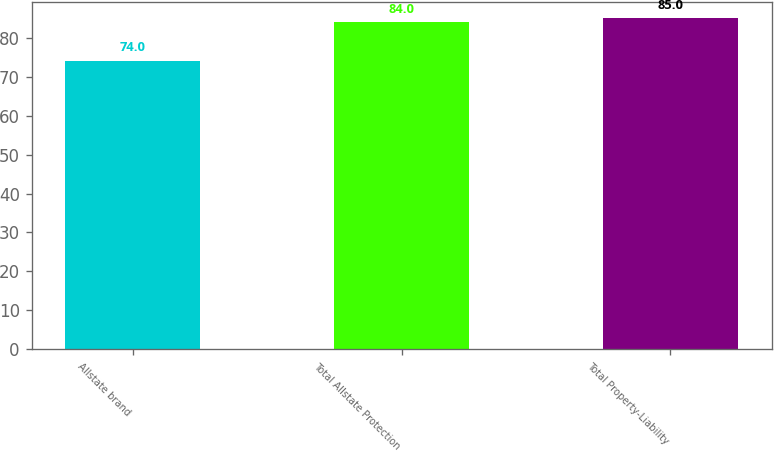Convert chart to OTSL. <chart><loc_0><loc_0><loc_500><loc_500><bar_chart><fcel>Allstate brand<fcel>Total Allstate Protection<fcel>Total Property-Liability<nl><fcel>74<fcel>84<fcel>85<nl></chart> 